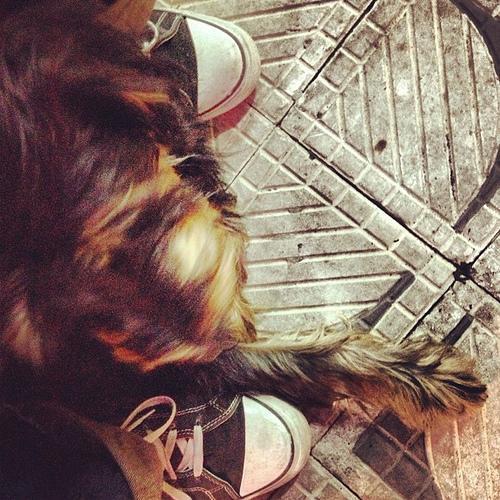How many shoes are shown?
Give a very brief answer. 2. 